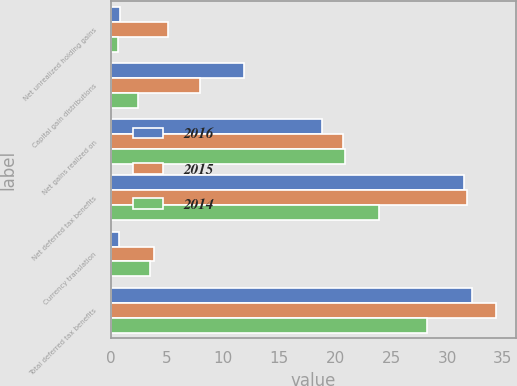<chart> <loc_0><loc_0><loc_500><loc_500><stacked_bar_chart><ecel><fcel>Net unrealized holding gains<fcel>Capital gain distributions<fcel>Net gains realized on<fcel>Net deferred tax benefits<fcel>Currency translation<fcel>Total deferred tax benefits<nl><fcel>2016<fcel>0.8<fcel>11.9<fcel>18.8<fcel>31.5<fcel>0.7<fcel>32.2<nl><fcel>2015<fcel>5.1<fcel>7.9<fcel>20.7<fcel>31.8<fcel>3.8<fcel>34.4<nl><fcel>2014<fcel>0.6<fcel>2.4<fcel>20.9<fcel>23.9<fcel>3.5<fcel>28.2<nl></chart> 